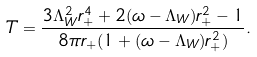Convert formula to latex. <formula><loc_0><loc_0><loc_500><loc_500>T = \frac { 3 \Lambda _ { W } ^ { 2 } r _ { + } ^ { 4 } + 2 ( \omega - \Lambda _ { W } ) r _ { + } ^ { 2 } - 1 } { 8 \pi r _ { + } ( 1 + ( \omega - \Lambda _ { W } ) r _ { + } ^ { 2 } ) } .</formula> 